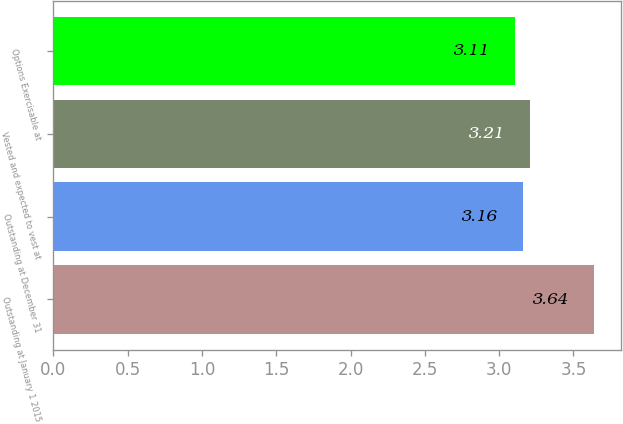Convert chart. <chart><loc_0><loc_0><loc_500><loc_500><bar_chart><fcel>Outstanding at January 1 2015<fcel>Outstanding at December 31<fcel>Vested and expected to vest at<fcel>Options Exercisable at<nl><fcel>3.64<fcel>3.16<fcel>3.21<fcel>3.11<nl></chart> 